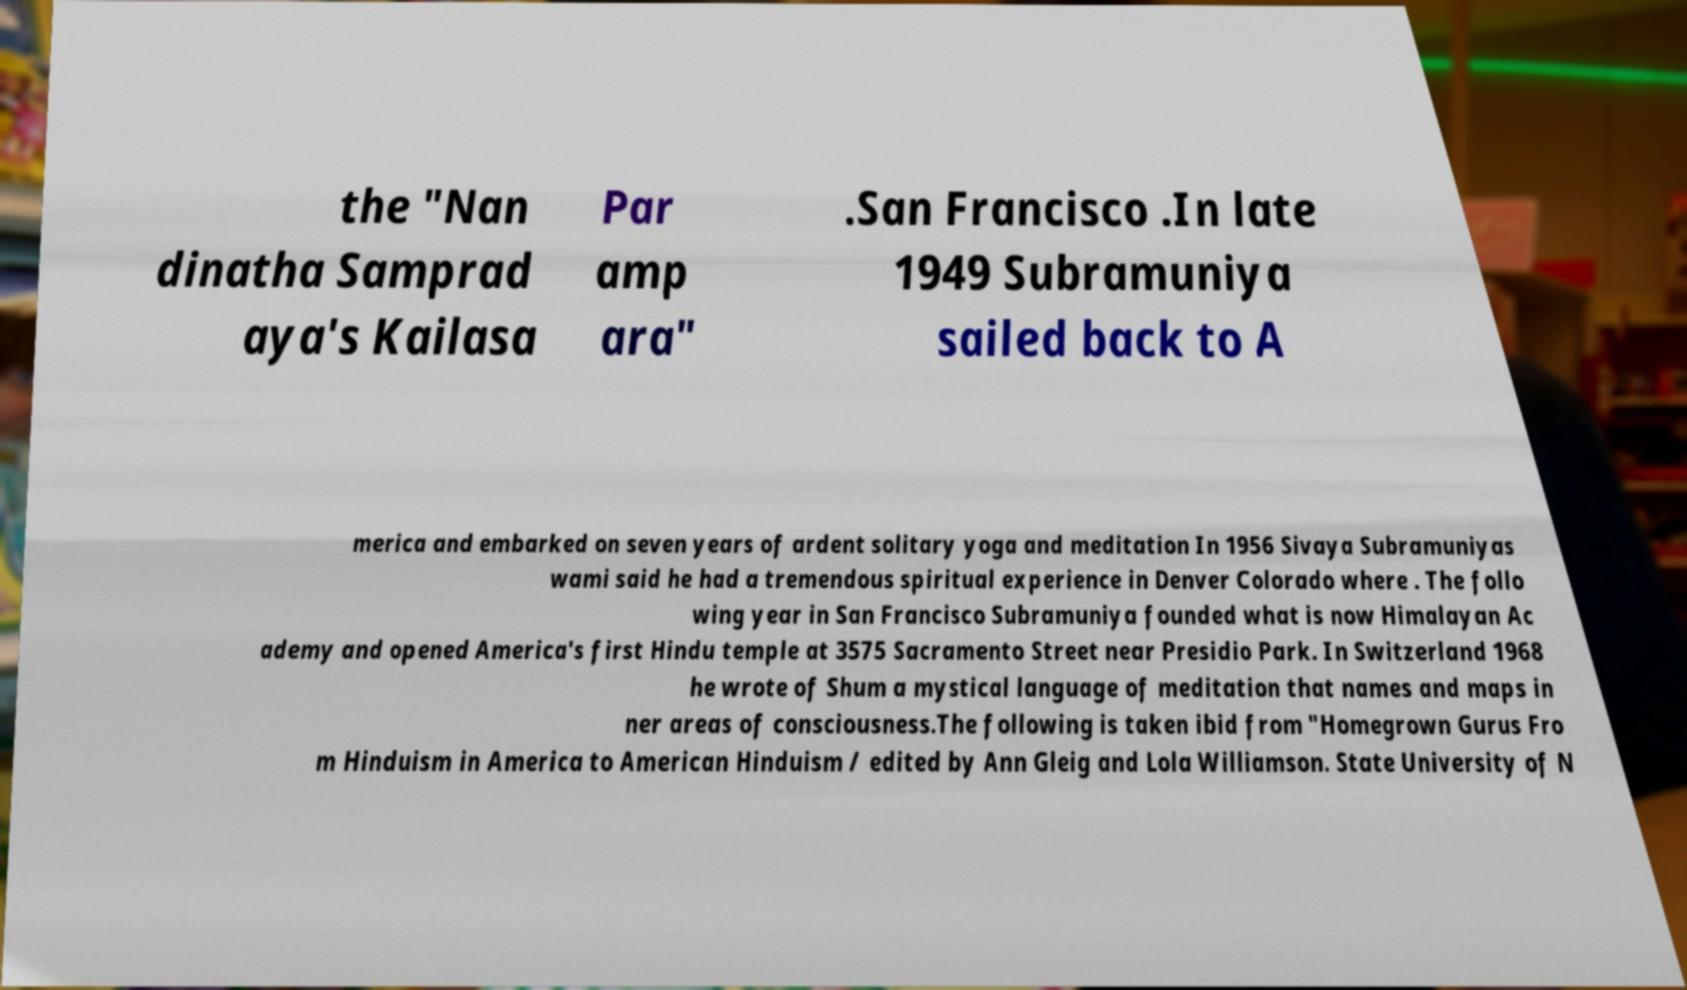Please identify and transcribe the text found in this image. the "Nan dinatha Samprad aya's Kailasa Par amp ara" .San Francisco .In late 1949 Subramuniya sailed back to A merica and embarked on seven years of ardent solitary yoga and meditation In 1956 Sivaya Subramuniyas wami said he had a tremendous spiritual experience in Denver Colorado where . The follo wing year in San Francisco Subramuniya founded what is now Himalayan Ac ademy and opened America's first Hindu temple at 3575 Sacramento Street near Presidio Park. In Switzerland 1968 he wrote of Shum a mystical language of meditation that names and maps in ner areas of consciousness.The following is taken ibid from "Homegrown Gurus Fro m Hinduism in America to American Hinduism / edited by Ann Gleig and Lola Williamson. State University of N 